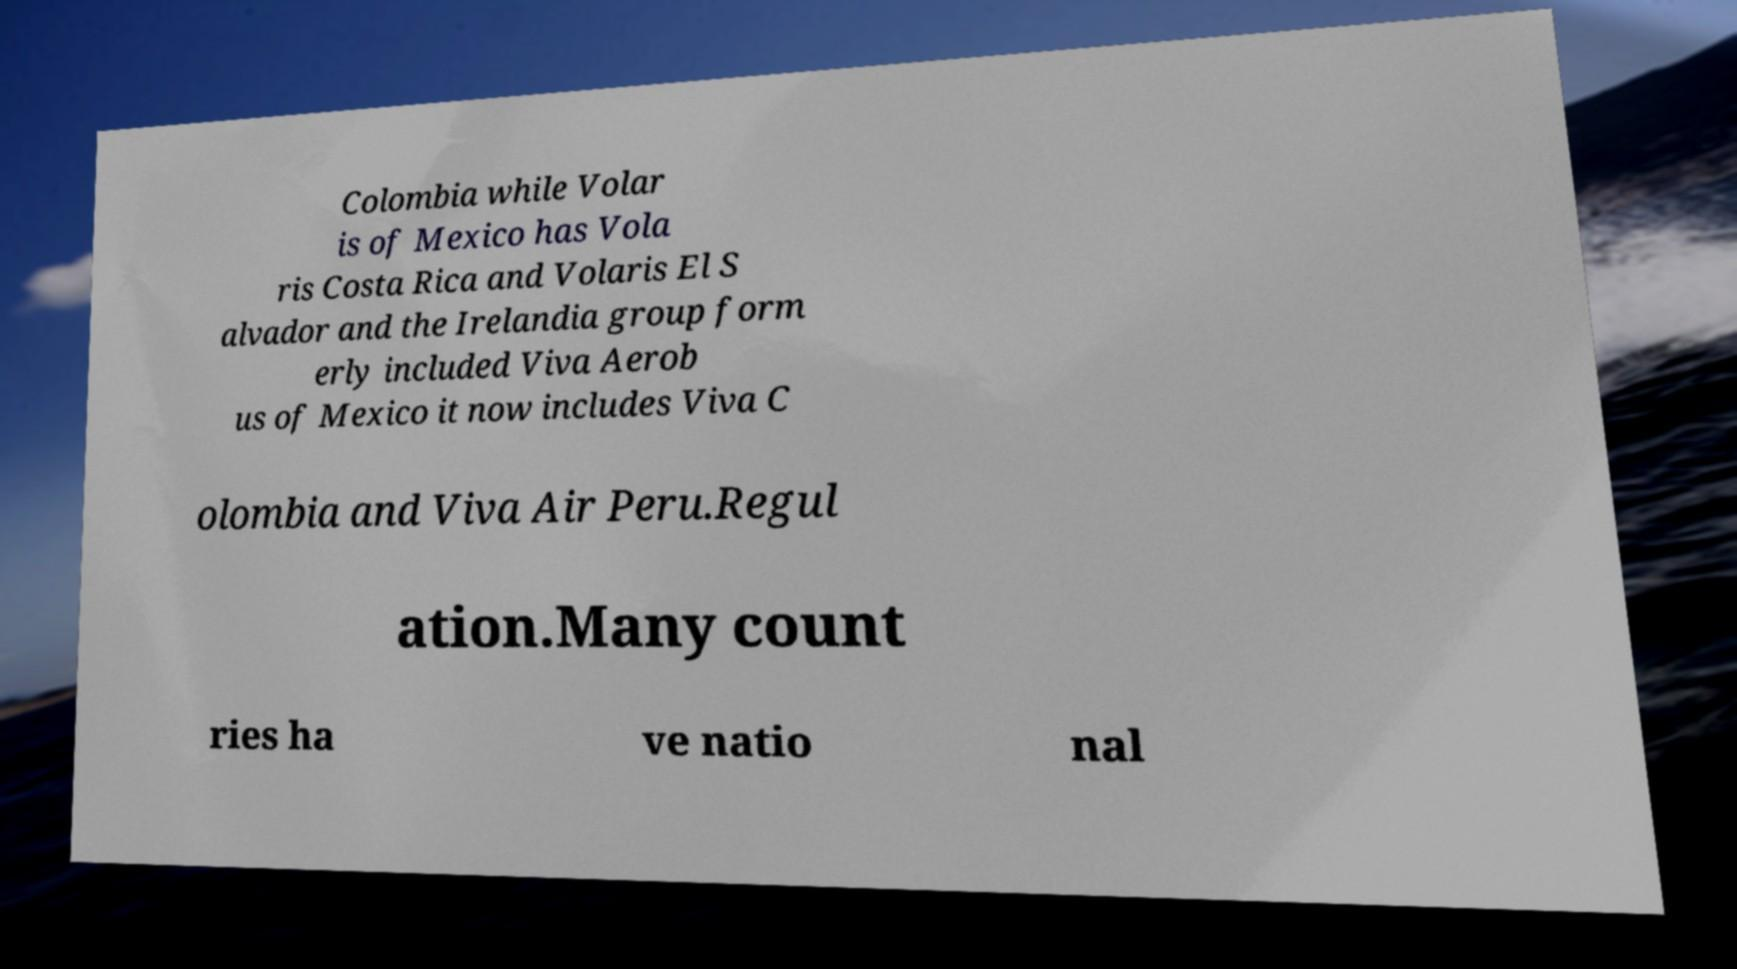Please identify and transcribe the text found in this image. Colombia while Volar is of Mexico has Vola ris Costa Rica and Volaris El S alvador and the Irelandia group form erly included Viva Aerob us of Mexico it now includes Viva C olombia and Viva Air Peru.Regul ation.Many count ries ha ve natio nal 